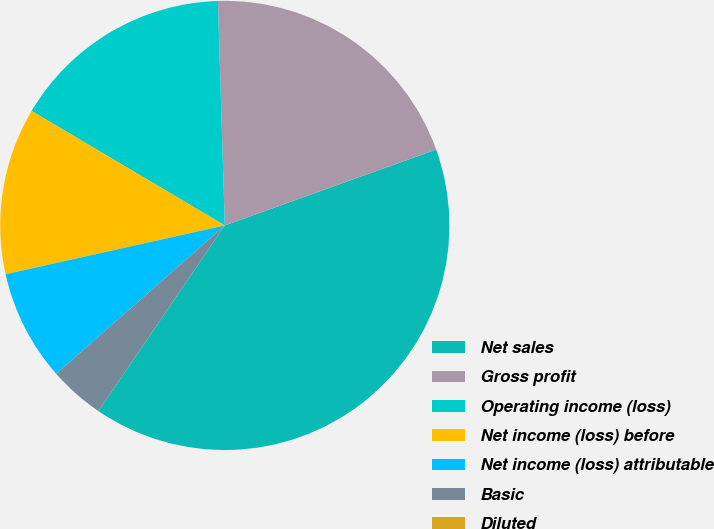Convert chart to OTSL. <chart><loc_0><loc_0><loc_500><loc_500><pie_chart><fcel>Net sales<fcel>Gross profit<fcel>Operating income (loss)<fcel>Net income (loss) before<fcel>Net income (loss) attributable<fcel>Basic<fcel>Diluted<nl><fcel>40.0%<fcel>20.0%<fcel>16.0%<fcel>12.0%<fcel>8.0%<fcel>4.0%<fcel>0.0%<nl></chart> 